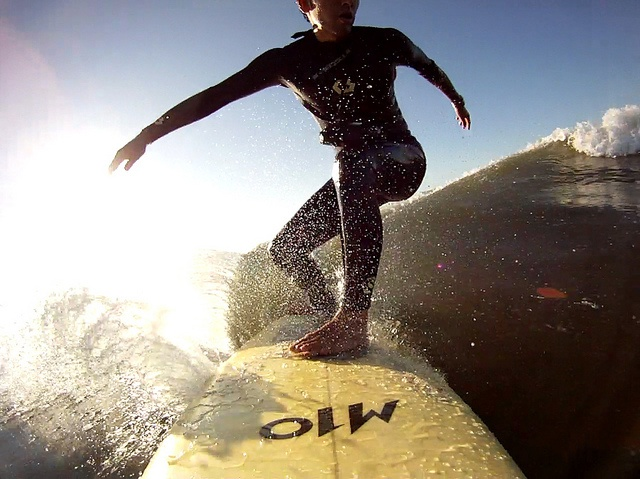Describe the objects in this image and their specific colors. I can see people in gray, black, maroon, and darkgray tones and surfboard in gray, tan, and khaki tones in this image. 